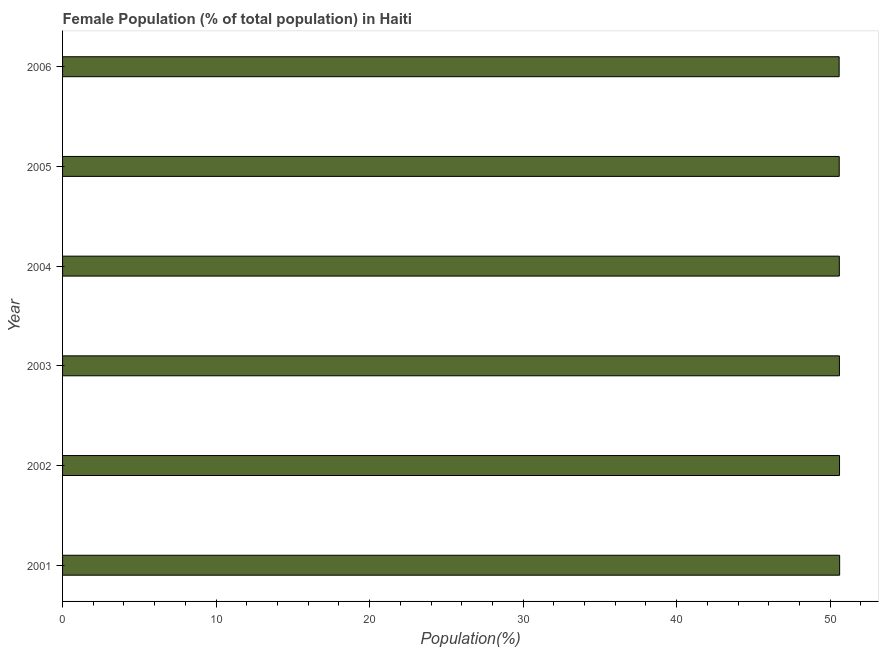What is the title of the graph?
Give a very brief answer. Female Population (% of total population) in Haiti. What is the label or title of the X-axis?
Make the answer very short. Population(%). What is the female population in 2002?
Give a very brief answer. 50.61. Across all years, what is the maximum female population?
Make the answer very short. 50.62. Across all years, what is the minimum female population?
Offer a terse response. 50.58. What is the sum of the female population?
Make the answer very short. 303.6. What is the difference between the female population in 2002 and 2003?
Make the answer very short. 0.01. What is the average female population per year?
Provide a succinct answer. 50.6. What is the median female population?
Ensure brevity in your answer.  50.6. In how many years, is the female population greater than 18 %?
Make the answer very short. 6. Is the female population in 2001 less than that in 2006?
Offer a terse response. No. What is the difference between the highest and the second highest female population?
Your answer should be compact. 0.01. In how many years, is the female population greater than the average female population taken over all years?
Ensure brevity in your answer.  3. How many bars are there?
Make the answer very short. 6. Are the values on the major ticks of X-axis written in scientific E-notation?
Your answer should be compact. No. What is the Population(%) in 2001?
Offer a terse response. 50.62. What is the Population(%) in 2002?
Offer a very short reply. 50.61. What is the Population(%) of 2003?
Your answer should be compact. 50.6. What is the Population(%) in 2004?
Your answer should be very brief. 50.6. What is the Population(%) in 2005?
Your answer should be very brief. 50.59. What is the Population(%) in 2006?
Ensure brevity in your answer.  50.58. What is the difference between the Population(%) in 2001 and 2002?
Give a very brief answer. 0.01. What is the difference between the Population(%) in 2001 and 2003?
Offer a very short reply. 0.01. What is the difference between the Population(%) in 2001 and 2004?
Offer a terse response. 0.02. What is the difference between the Population(%) in 2001 and 2005?
Keep it short and to the point. 0.03. What is the difference between the Population(%) in 2001 and 2006?
Offer a very short reply. 0.03. What is the difference between the Population(%) in 2002 and 2003?
Your answer should be compact. 0.01. What is the difference between the Population(%) in 2002 and 2004?
Keep it short and to the point. 0.01. What is the difference between the Population(%) in 2002 and 2005?
Provide a succinct answer. 0.02. What is the difference between the Population(%) in 2002 and 2006?
Your answer should be very brief. 0.02. What is the difference between the Population(%) in 2003 and 2004?
Your response must be concise. 0.01. What is the difference between the Population(%) in 2003 and 2005?
Offer a terse response. 0.01. What is the difference between the Population(%) in 2003 and 2006?
Ensure brevity in your answer.  0.02. What is the difference between the Population(%) in 2004 and 2005?
Give a very brief answer. 0.01. What is the difference between the Population(%) in 2004 and 2006?
Your response must be concise. 0.01. What is the difference between the Population(%) in 2005 and 2006?
Your answer should be compact. 0.01. What is the ratio of the Population(%) in 2001 to that in 2004?
Provide a short and direct response. 1. What is the ratio of the Population(%) in 2001 to that in 2006?
Offer a terse response. 1. What is the ratio of the Population(%) in 2003 to that in 2004?
Your answer should be very brief. 1. What is the ratio of the Population(%) in 2004 to that in 2006?
Provide a succinct answer. 1. 